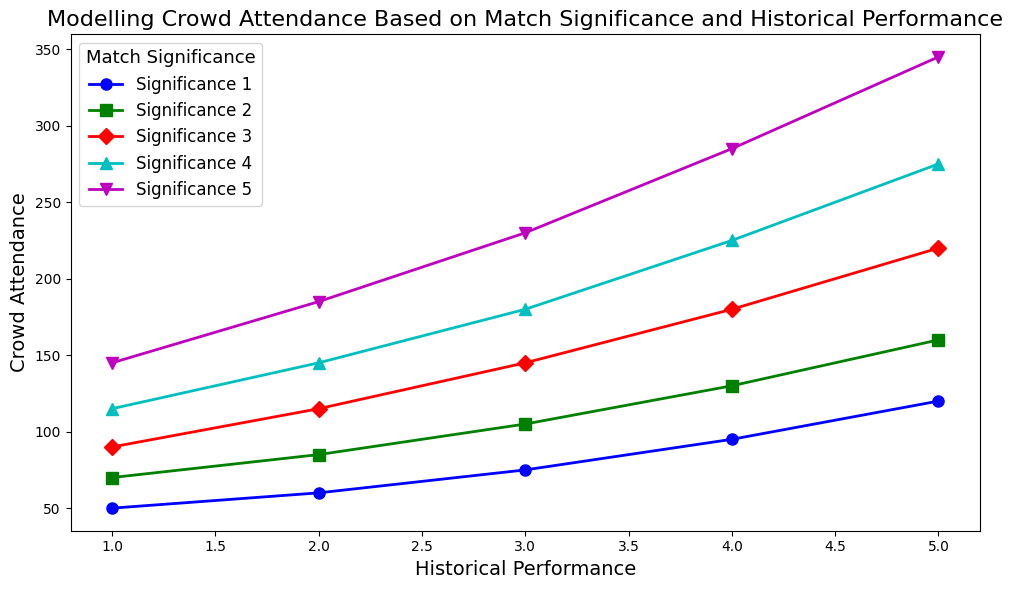How does crowd attendance change with increasing historical performance for a match significance of 3? Visually observe the curve for match significance 3 (e.g., marked by a specific color and marker). Notice how the points for Historical Performance (HP) 1, 2, 3, 4, and 5 move. You'll see that Crowd Attendance (CA) increases as HP increases: from 90 to 220.
Answer: Increases What is the crowd attendance difference between match significance 5 and match significance 1 for a historical performance of 2? Find the CA for Historical Performance 2 with match significances 5 and 1. For significance 5 (green, for example), CA is 185. For significance 1 (blue, for example), CA is 60. Subtract the lower value from the higher value: 185 - 60.
Answer: 125 Which match significance resulted in the highest crowd attendance for a historical performance of 5? Locate all points for HP 5 and identify the CA. Compare the CAs: for match significances 1, 2, 3, 4, and 5; they are 120, 160, 220, 275, and 345 respectively. The highest CA corresponds to significance 5.
Answer: Match Significance 5 For match significance 2, what is the average crowd attendance across all historical performance levels? Sum CAs for all HP levels within match significance 2: 70 (HP 1), 85 (HP 2), 105 (HP 3), 130 (HP 4), 160 (HP 5). Calculate the sum: 70 + 85 + 105 + 130 + 160 = 550. The average is 550 divided by the number of levels (5).
Answer: 110 Which match significance level shows the steepest increase in crowd attendance as historical performance improves from 1 to 5? Visually identify lines corresponding to each significance level and observe their slopes. The steepest line (greatest vertical rise over horizontal run) indicates the steepest increase.
Answer: Match Significance 5 Is the increase in crowd attendance from historical performance 2 to 3 greater for match significance 4 or 5? Compare the changes for HP 2 to 3: For significance 4, CA changes from 145 to 180 (35 increase). For significance 5, CA changes from 185 to 230 (45 increase).
Answer: Match Significance 5 What color represents match significance 1? Observe the color coding in the legend for match significance 1, visible as the plotted line and marker.
Answer: Blue 